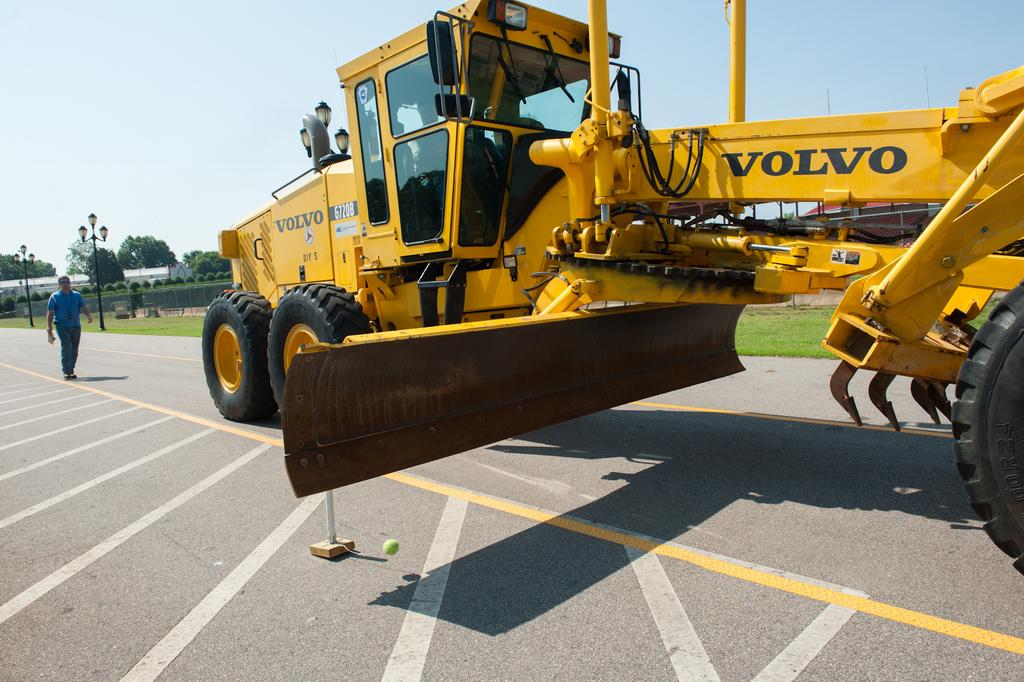<image>
Summarize the visual content of the image. a volvo truck that is outside for some reason. 